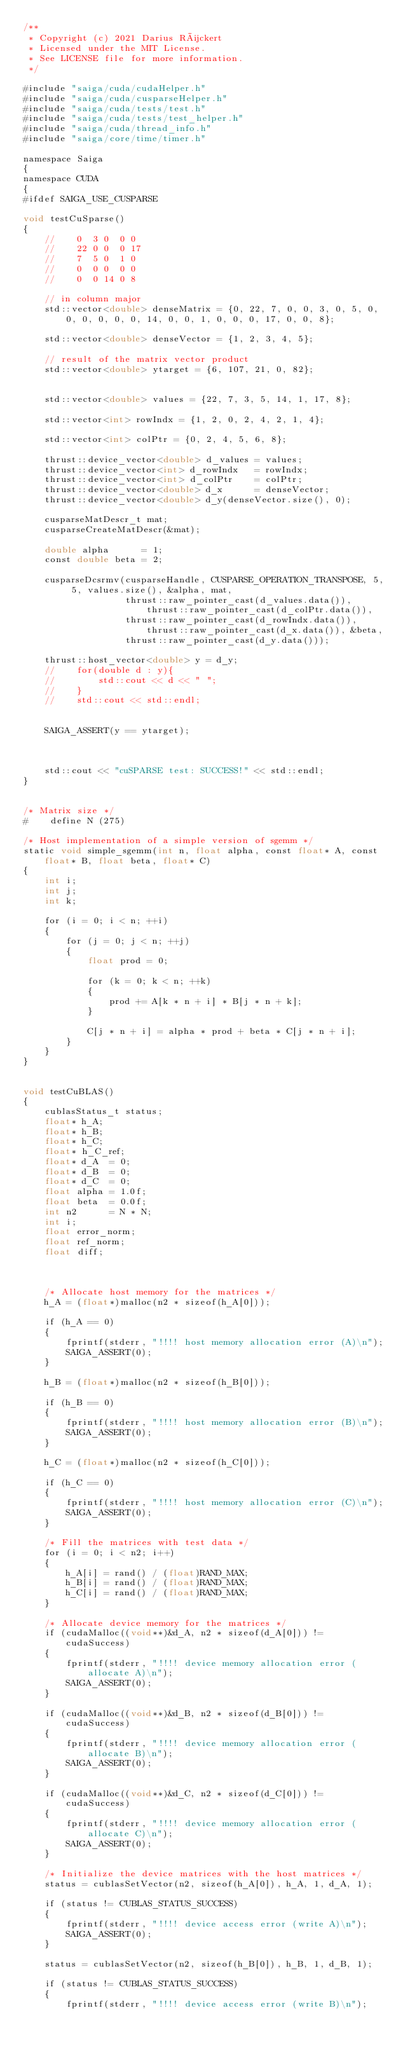Convert code to text. <code><loc_0><loc_0><loc_500><loc_500><_Cuda_>/**
 * Copyright (c) 2021 Darius Rückert
 * Licensed under the MIT License.
 * See LICENSE file for more information.
 */

#include "saiga/cuda/cudaHelper.h"
#include "saiga/cuda/cusparseHelper.h"
#include "saiga/cuda/tests/test.h"
#include "saiga/cuda/tests/test_helper.h"
#include "saiga/cuda/thread_info.h"
#include "saiga/core/time/timer.h"

namespace Saiga
{
namespace CUDA
{
#ifdef SAIGA_USE_CUSPARSE

void testCuSparse()
{
    //    0  3 0  0 0
    //    22 0 0  0 17
    //    7  5 0  1 0
    //    0  0 0  0 0
    //    0  0 14 0 8

    // in column major
    std::vector<double> denseMatrix = {0, 22, 7, 0, 0, 3, 0, 5, 0, 0, 0, 0, 0, 0, 14, 0, 0, 1, 0, 0, 0, 17, 0, 0, 8};

    std::vector<double> denseVector = {1, 2, 3, 4, 5};

    // result of the matrix vector product
    std::vector<double> ytarget = {6, 107, 21, 0, 82};


    std::vector<double> values = {22, 7, 3, 5, 14, 1, 17, 8};

    std::vector<int> rowIndx = {1, 2, 0, 2, 4, 2, 1, 4};

    std::vector<int> colPtr = {0, 2, 4, 5, 6, 8};

    thrust::device_vector<double> d_values = values;
    thrust::device_vector<int> d_rowIndx   = rowIndx;
    thrust::device_vector<int> d_colPtr    = colPtr;
    thrust::device_vector<double> d_x      = denseVector;
    thrust::device_vector<double> d_y(denseVector.size(), 0);

    cusparseMatDescr_t mat;
    cusparseCreateMatDescr(&mat);

    double alpha      = 1;
    const double beta = 2;

    cusparseDcsrmv(cusparseHandle, CUSPARSE_OPERATION_TRANSPOSE, 5, 5, values.size(), &alpha, mat,
                   thrust::raw_pointer_cast(d_values.data()), thrust::raw_pointer_cast(d_colPtr.data()),
                   thrust::raw_pointer_cast(d_rowIndx.data()), thrust::raw_pointer_cast(d_x.data()), &beta,
                   thrust::raw_pointer_cast(d_y.data()));

    thrust::host_vector<double> y = d_y;
    //    for(double d : y){
    //        std::cout << d << " ";
    //    }
    //    std::cout << std::endl;


    SAIGA_ASSERT(y == ytarget);



    std::cout << "cuSPARSE test: SUCCESS!" << std::endl;
}


/* Matrix size */
#    define N (275)

/* Host implementation of a simple version of sgemm */
static void simple_sgemm(int n, float alpha, const float* A, const float* B, float beta, float* C)
{
    int i;
    int j;
    int k;

    for (i = 0; i < n; ++i)
    {
        for (j = 0; j < n; ++j)
        {
            float prod = 0;

            for (k = 0; k < n; ++k)
            {
                prod += A[k * n + i] * B[j * n + k];
            }

            C[j * n + i] = alpha * prod + beta * C[j * n + i];
        }
    }
}


void testCuBLAS()
{
    cublasStatus_t status;
    float* h_A;
    float* h_B;
    float* h_C;
    float* h_C_ref;
    float* d_A  = 0;
    float* d_B  = 0;
    float* d_C  = 0;
    float alpha = 1.0f;
    float beta  = 0.0f;
    int n2      = N * N;
    int i;
    float error_norm;
    float ref_norm;
    float diff;



    /* Allocate host memory for the matrices */
    h_A = (float*)malloc(n2 * sizeof(h_A[0]));

    if (h_A == 0)
    {
        fprintf(stderr, "!!!! host memory allocation error (A)\n");
        SAIGA_ASSERT(0);
    }

    h_B = (float*)malloc(n2 * sizeof(h_B[0]));

    if (h_B == 0)
    {
        fprintf(stderr, "!!!! host memory allocation error (B)\n");
        SAIGA_ASSERT(0);
    }

    h_C = (float*)malloc(n2 * sizeof(h_C[0]));

    if (h_C == 0)
    {
        fprintf(stderr, "!!!! host memory allocation error (C)\n");
        SAIGA_ASSERT(0);
    }

    /* Fill the matrices with test data */
    for (i = 0; i < n2; i++)
    {
        h_A[i] = rand() / (float)RAND_MAX;
        h_B[i] = rand() / (float)RAND_MAX;
        h_C[i] = rand() / (float)RAND_MAX;
    }

    /* Allocate device memory for the matrices */
    if (cudaMalloc((void**)&d_A, n2 * sizeof(d_A[0])) != cudaSuccess)
    {
        fprintf(stderr, "!!!! device memory allocation error (allocate A)\n");
        SAIGA_ASSERT(0);
    }

    if (cudaMalloc((void**)&d_B, n2 * sizeof(d_B[0])) != cudaSuccess)
    {
        fprintf(stderr, "!!!! device memory allocation error (allocate B)\n");
        SAIGA_ASSERT(0);
    }

    if (cudaMalloc((void**)&d_C, n2 * sizeof(d_C[0])) != cudaSuccess)
    {
        fprintf(stderr, "!!!! device memory allocation error (allocate C)\n");
        SAIGA_ASSERT(0);
    }

    /* Initialize the device matrices with the host matrices */
    status = cublasSetVector(n2, sizeof(h_A[0]), h_A, 1, d_A, 1);

    if (status != CUBLAS_STATUS_SUCCESS)
    {
        fprintf(stderr, "!!!! device access error (write A)\n");
        SAIGA_ASSERT(0);
    }

    status = cublasSetVector(n2, sizeof(h_B[0]), h_B, 1, d_B, 1);

    if (status != CUBLAS_STATUS_SUCCESS)
    {
        fprintf(stderr, "!!!! device access error (write B)\n");</code> 